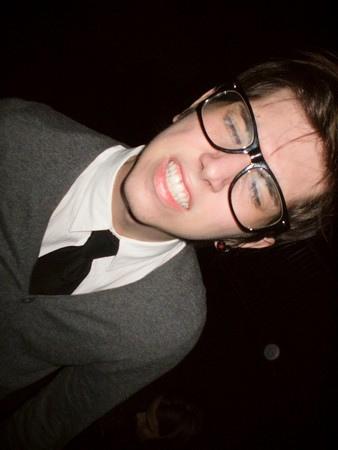What is the kid doing?
Answer briefly. Smiling. Is this man a blonde?
Quick response, please. No. Are the man's eyes open?
Be succinct. No. Who has glasses?
Be succinct. Man. 